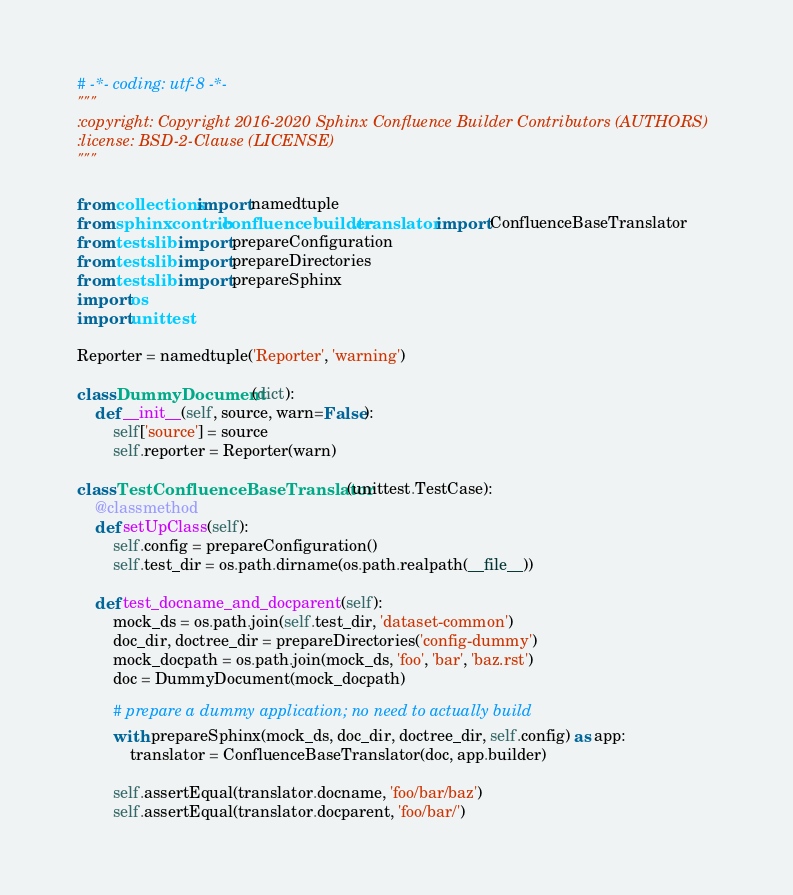Convert code to text. <code><loc_0><loc_0><loc_500><loc_500><_Python_># -*- coding: utf-8 -*-
"""
:copyright: Copyright 2016-2020 Sphinx Confluence Builder Contributors (AUTHORS)
:license: BSD-2-Clause (LICENSE)
"""

from collections import namedtuple
from sphinxcontrib.confluencebuilder.translator import ConfluenceBaseTranslator
from tests.lib import prepareConfiguration
from tests.lib import prepareDirectories
from tests.lib import prepareSphinx
import os
import unittest

Reporter = namedtuple('Reporter', 'warning')

class DummyDocument(dict):
    def __init__(self, source, warn=False):
        self['source'] = source
        self.reporter = Reporter(warn)

class TestConfluenceBaseTranslator(unittest.TestCase):
    @classmethod
    def setUpClass(self):
        self.config = prepareConfiguration()
        self.test_dir = os.path.dirname(os.path.realpath(__file__))

    def test_docname_and_docparent(self):
        mock_ds = os.path.join(self.test_dir, 'dataset-common')
        doc_dir, doctree_dir = prepareDirectories('config-dummy')
        mock_docpath = os.path.join(mock_ds, 'foo', 'bar', 'baz.rst')
        doc = DummyDocument(mock_docpath)

        # prepare a dummy application; no need to actually build
        with prepareSphinx(mock_ds, doc_dir, doctree_dir, self.config) as app:
            translator = ConfluenceBaseTranslator(doc, app.builder)

        self.assertEqual(translator.docname, 'foo/bar/baz')
        self.assertEqual(translator.docparent, 'foo/bar/')
</code> 